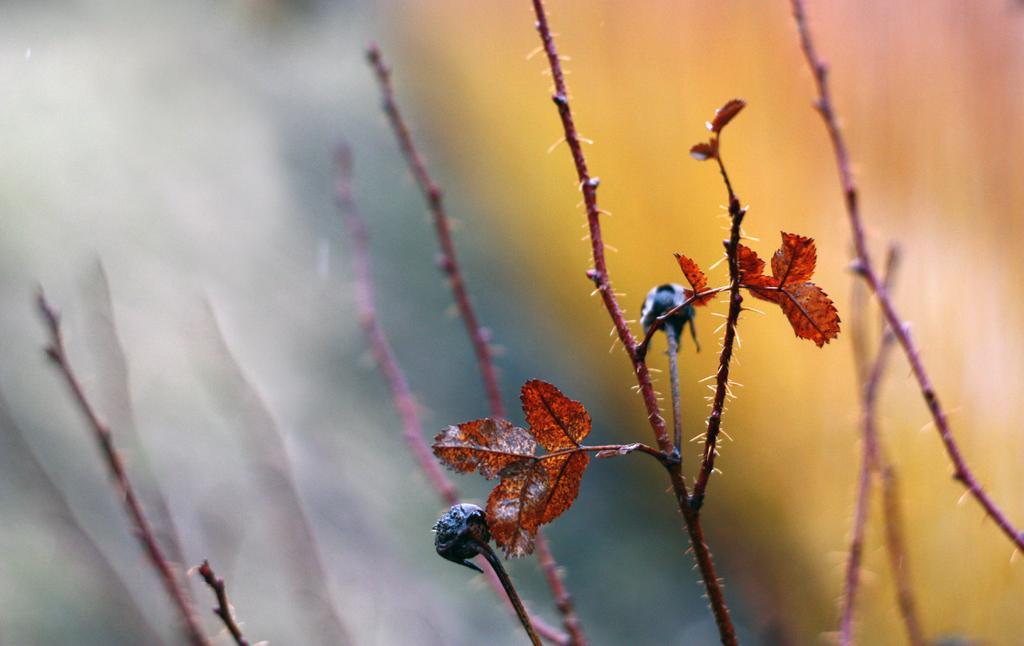Please provide a concise description of this image. In this image we can see woody plant image and there are leaves. 